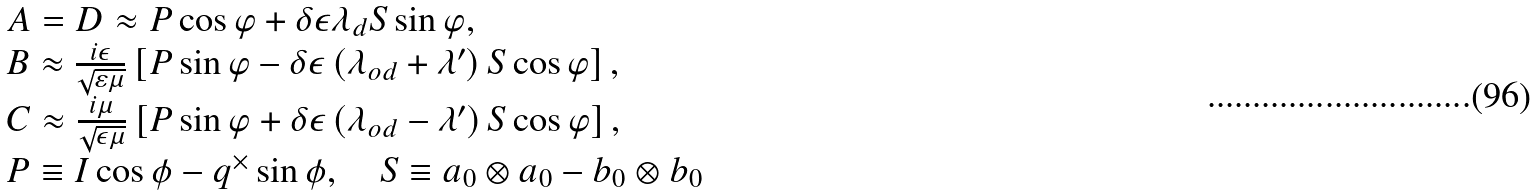<formula> <loc_0><loc_0><loc_500><loc_500>\begin{array} { l } A = D \approx P \cos \varphi + \delta \epsilon \lambda _ { d } S \sin \varphi , \\ B \approx \frac { i \epsilon } { \sqrt { \varepsilon \mu } } \left [ P \sin \varphi - \delta \epsilon \left ( \lambda _ { o d } + \lambda ^ { \prime } \right ) S \cos \varphi \right ] , \\ C \approx \frac { i \mu } { \sqrt { \epsilon \mu } } \left [ P \sin \varphi + \delta \epsilon \left ( \lambda _ { o d } - \lambda ^ { \prime } \right ) S \cos \varphi \right ] , \\ P \equiv I \cos \phi - q ^ { \times } \sin \phi , \quad S \equiv a _ { 0 } \otimes a _ { 0 } - b _ { 0 } \otimes b _ { 0 } \end{array}</formula> 